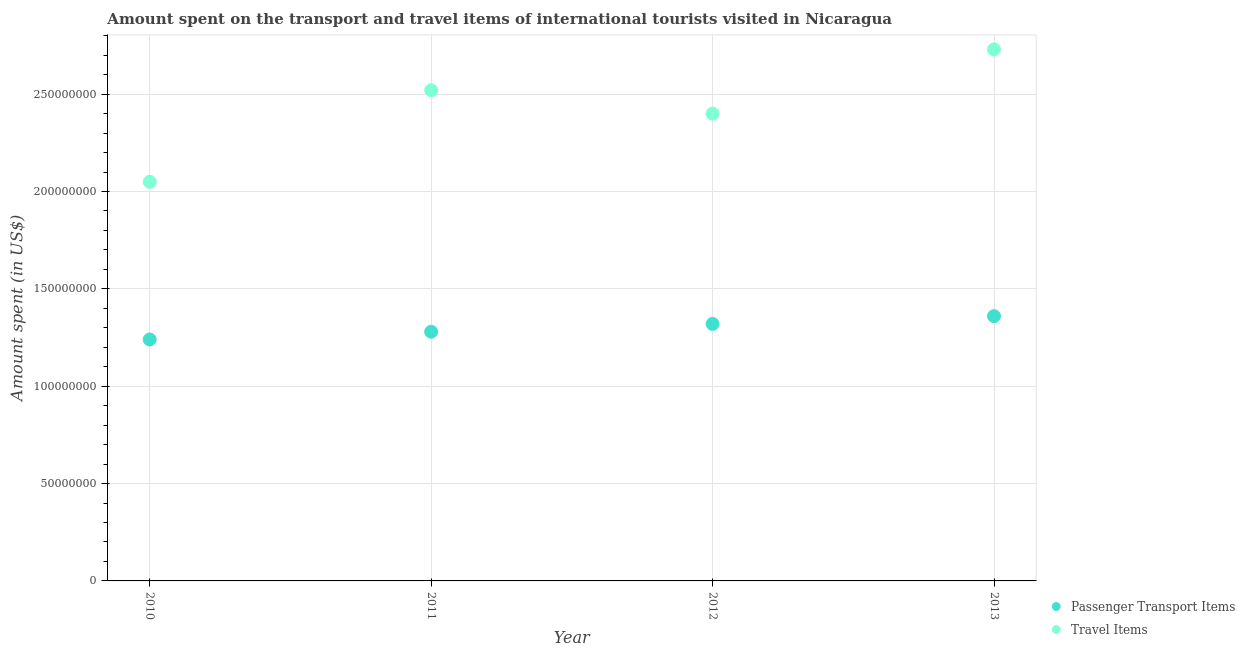Is the number of dotlines equal to the number of legend labels?
Provide a short and direct response. Yes. What is the amount spent in travel items in 2011?
Give a very brief answer. 2.52e+08. Across all years, what is the maximum amount spent in travel items?
Offer a terse response. 2.73e+08. Across all years, what is the minimum amount spent in travel items?
Offer a very short reply. 2.05e+08. In which year was the amount spent in travel items maximum?
Offer a very short reply. 2013. What is the total amount spent on passenger transport items in the graph?
Provide a succinct answer. 5.20e+08. What is the difference between the amount spent on passenger transport items in 2010 and that in 2011?
Your answer should be compact. -4.00e+06. What is the difference between the amount spent on passenger transport items in 2012 and the amount spent in travel items in 2013?
Keep it short and to the point. -1.41e+08. What is the average amount spent on passenger transport items per year?
Keep it short and to the point. 1.30e+08. In the year 2010, what is the difference between the amount spent on passenger transport items and amount spent in travel items?
Your answer should be very brief. -8.10e+07. In how many years, is the amount spent on passenger transport items greater than 130000000 US$?
Give a very brief answer. 2. What is the ratio of the amount spent in travel items in 2010 to that in 2011?
Your response must be concise. 0.81. Is the amount spent on passenger transport items in 2010 less than that in 2013?
Your answer should be compact. Yes. What is the difference between the highest and the second highest amount spent in travel items?
Provide a succinct answer. 2.10e+07. What is the difference between the highest and the lowest amount spent on passenger transport items?
Give a very brief answer. 1.20e+07. Is the sum of the amount spent on passenger transport items in 2011 and 2012 greater than the maximum amount spent in travel items across all years?
Provide a succinct answer. No. Does the amount spent on passenger transport items monotonically increase over the years?
Offer a very short reply. Yes. Is the amount spent on passenger transport items strictly greater than the amount spent in travel items over the years?
Give a very brief answer. No. Is the amount spent in travel items strictly less than the amount spent on passenger transport items over the years?
Make the answer very short. No. What is the difference between two consecutive major ticks on the Y-axis?
Offer a very short reply. 5.00e+07. Are the values on the major ticks of Y-axis written in scientific E-notation?
Make the answer very short. No. Does the graph contain grids?
Your answer should be compact. Yes. Where does the legend appear in the graph?
Provide a short and direct response. Bottom right. How many legend labels are there?
Keep it short and to the point. 2. How are the legend labels stacked?
Offer a terse response. Vertical. What is the title of the graph?
Offer a terse response. Amount spent on the transport and travel items of international tourists visited in Nicaragua. What is the label or title of the X-axis?
Your answer should be very brief. Year. What is the label or title of the Y-axis?
Your answer should be compact. Amount spent (in US$). What is the Amount spent (in US$) of Passenger Transport Items in 2010?
Provide a short and direct response. 1.24e+08. What is the Amount spent (in US$) in Travel Items in 2010?
Provide a short and direct response. 2.05e+08. What is the Amount spent (in US$) of Passenger Transport Items in 2011?
Give a very brief answer. 1.28e+08. What is the Amount spent (in US$) of Travel Items in 2011?
Your answer should be compact. 2.52e+08. What is the Amount spent (in US$) in Passenger Transport Items in 2012?
Make the answer very short. 1.32e+08. What is the Amount spent (in US$) of Travel Items in 2012?
Provide a short and direct response. 2.40e+08. What is the Amount spent (in US$) of Passenger Transport Items in 2013?
Ensure brevity in your answer.  1.36e+08. What is the Amount spent (in US$) in Travel Items in 2013?
Ensure brevity in your answer.  2.73e+08. Across all years, what is the maximum Amount spent (in US$) of Passenger Transport Items?
Make the answer very short. 1.36e+08. Across all years, what is the maximum Amount spent (in US$) in Travel Items?
Keep it short and to the point. 2.73e+08. Across all years, what is the minimum Amount spent (in US$) in Passenger Transport Items?
Provide a short and direct response. 1.24e+08. Across all years, what is the minimum Amount spent (in US$) in Travel Items?
Give a very brief answer. 2.05e+08. What is the total Amount spent (in US$) of Passenger Transport Items in the graph?
Ensure brevity in your answer.  5.20e+08. What is the total Amount spent (in US$) in Travel Items in the graph?
Provide a short and direct response. 9.70e+08. What is the difference between the Amount spent (in US$) of Passenger Transport Items in 2010 and that in 2011?
Ensure brevity in your answer.  -4.00e+06. What is the difference between the Amount spent (in US$) in Travel Items in 2010 and that in 2011?
Ensure brevity in your answer.  -4.70e+07. What is the difference between the Amount spent (in US$) in Passenger Transport Items in 2010 and that in 2012?
Give a very brief answer. -8.00e+06. What is the difference between the Amount spent (in US$) of Travel Items in 2010 and that in 2012?
Your answer should be very brief. -3.50e+07. What is the difference between the Amount spent (in US$) in Passenger Transport Items in 2010 and that in 2013?
Keep it short and to the point. -1.20e+07. What is the difference between the Amount spent (in US$) of Travel Items in 2010 and that in 2013?
Make the answer very short. -6.80e+07. What is the difference between the Amount spent (in US$) of Passenger Transport Items in 2011 and that in 2012?
Make the answer very short. -4.00e+06. What is the difference between the Amount spent (in US$) of Passenger Transport Items in 2011 and that in 2013?
Your response must be concise. -8.00e+06. What is the difference between the Amount spent (in US$) in Travel Items in 2011 and that in 2013?
Offer a very short reply. -2.10e+07. What is the difference between the Amount spent (in US$) of Passenger Transport Items in 2012 and that in 2013?
Give a very brief answer. -4.00e+06. What is the difference between the Amount spent (in US$) in Travel Items in 2012 and that in 2013?
Make the answer very short. -3.30e+07. What is the difference between the Amount spent (in US$) of Passenger Transport Items in 2010 and the Amount spent (in US$) of Travel Items in 2011?
Give a very brief answer. -1.28e+08. What is the difference between the Amount spent (in US$) of Passenger Transport Items in 2010 and the Amount spent (in US$) of Travel Items in 2012?
Provide a short and direct response. -1.16e+08. What is the difference between the Amount spent (in US$) of Passenger Transport Items in 2010 and the Amount spent (in US$) of Travel Items in 2013?
Your response must be concise. -1.49e+08. What is the difference between the Amount spent (in US$) in Passenger Transport Items in 2011 and the Amount spent (in US$) in Travel Items in 2012?
Your answer should be compact. -1.12e+08. What is the difference between the Amount spent (in US$) of Passenger Transport Items in 2011 and the Amount spent (in US$) of Travel Items in 2013?
Your answer should be compact. -1.45e+08. What is the difference between the Amount spent (in US$) in Passenger Transport Items in 2012 and the Amount spent (in US$) in Travel Items in 2013?
Offer a terse response. -1.41e+08. What is the average Amount spent (in US$) in Passenger Transport Items per year?
Keep it short and to the point. 1.30e+08. What is the average Amount spent (in US$) in Travel Items per year?
Your response must be concise. 2.42e+08. In the year 2010, what is the difference between the Amount spent (in US$) in Passenger Transport Items and Amount spent (in US$) in Travel Items?
Ensure brevity in your answer.  -8.10e+07. In the year 2011, what is the difference between the Amount spent (in US$) of Passenger Transport Items and Amount spent (in US$) of Travel Items?
Offer a very short reply. -1.24e+08. In the year 2012, what is the difference between the Amount spent (in US$) of Passenger Transport Items and Amount spent (in US$) of Travel Items?
Offer a very short reply. -1.08e+08. In the year 2013, what is the difference between the Amount spent (in US$) of Passenger Transport Items and Amount spent (in US$) of Travel Items?
Make the answer very short. -1.37e+08. What is the ratio of the Amount spent (in US$) in Passenger Transport Items in 2010 to that in 2011?
Your answer should be very brief. 0.97. What is the ratio of the Amount spent (in US$) in Travel Items in 2010 to that in 2011?
Offer a very short reply. 0.81. What is the ratio of the Amount spent (in US$) of Passenger Transport Items in 2010 to that in 2012?
Make the answer very short. 0.94. What is the ratio of the Amount spent (in US$) in Travel Items in 2010 to that in 2012?
Your response must be concise. 0.85. What is the ratio of the Amount spent (in US$) of Passenger Transport Items in 2010 to that in 2013?
Give a very brief answer. 0.91. What is the ratio of the Amount spent (in US$) of Travel Items in 2010 to that in 2013?
Provide a succinct answer. 0.75. What is the ratio of the Amount spent (in US$) in Passenger Transport Items in 2011 to that in 2012?
Offer a terse response. 0.97. What is the ratio of the Amount spent (in US$) in Passenger Transport Items in 2011 to that in 2013?
Provide a short and direct response. 0.94. What is the ratio of the Amount spent (in US$) in Travel Items in 2011 to that in 2013?
Your answer should be very brief. 0.92. What is the ratio of the Amount spent (in US$) in Passenger Transport Items in 2012 to that in 2013?
Keep it short and to the point. 0.97. What is the ratio of the Amount spent (in US$) of Travel Items in 2012 to that in 2013?
Give a very brief answer. 0.88. What is the difference between the highest and the second highest Amount spent (in US$) of Passenger Transport Items?
Make the answer very short. 4.00e+06. What is the difference between the highest and the second highest Amount spent (in US$) in Travel Items?
Your answer should be very brief. 2.10e+07. What is the difference between the highest and the lowest Amount spent (in US$) of Travel Items?
Your answer should be very brief. 6.80e+07. 